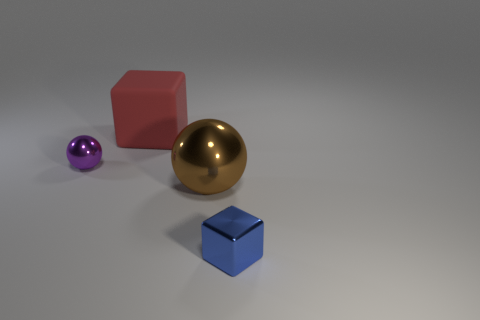How big is the object that is both to the right of the large rubber block and behind the blue metal cube?
Offer a terse response. Large. Is there any other thing that is made of the same material as the big red thing?
Provide a short and direct response. No. Is the tiny purple ball made of the same material as the small object on the right side of the brown metal ball?
Provide a succinct answer. Yes. Is the number of large matte things on the right side of the matte thing less than the number of purple metallic balls behind the blue object?
Keep it short and to the point. Yes. What is the block left of the large brown metallic ball made of?
Your response must be concise. Rubber. The metal object that is both on the right side of the purple metallic object and left of the blue cube is what color?
Offer a very short reply. Brown. What number of other objects are there of the same color as the tiny ball?
Give a very brief answer. 0. What color is the small thing that is left of the big ball?
Ensure brevity in your answer.  Purple. Are there any brown shiny balls that have the same size as the red matte thing?
Your answer should be very brief. Yes. There is another thing that is the same size as the purple metal object; what is its material?
Keep it short and to the point. Metal. 